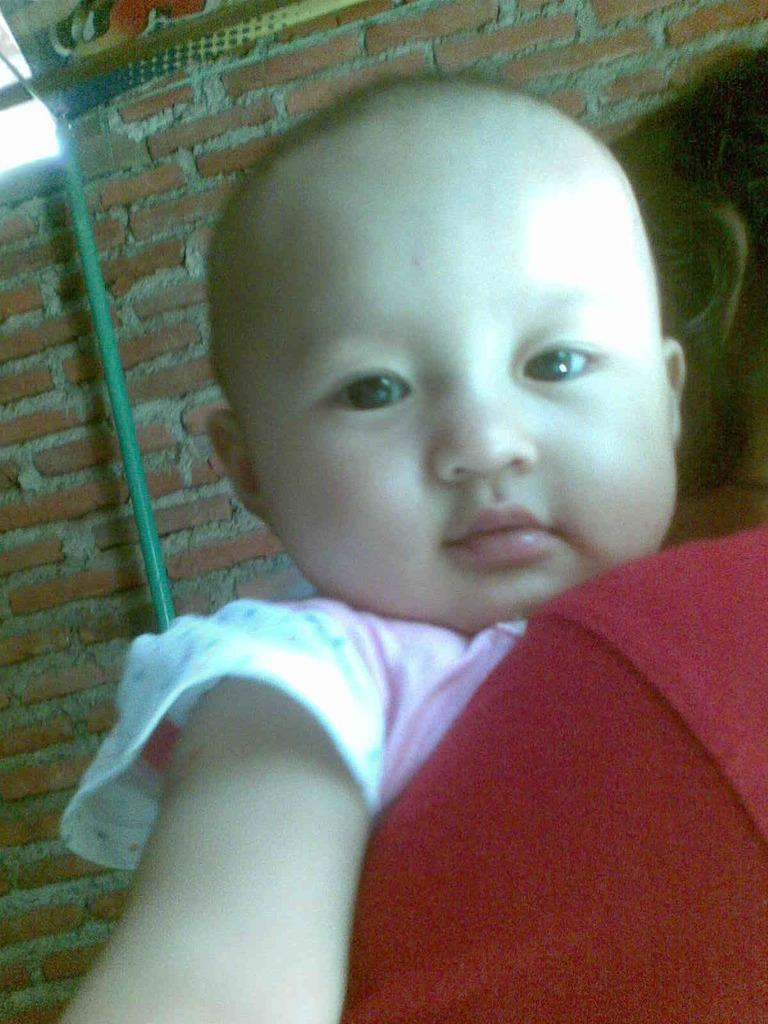Who is present in the image? There is a woman in the image. What is the woman holding? The woman is holding a baby. What type of structure can be seen in the background? There is a brick wall in the image. What other object is visible in the image? There is a pole in the image. What type of oatmeal is being prepared in the image? There is no oatmeal present in the image, so it cannot be determined if any is being prepared. 